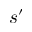Convert formula to latex. <formula><loc_0><loc_0><loc_500><loc_500>s ^ { \prime }</formula> 